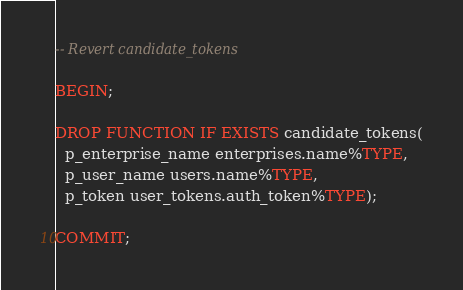Convert code to text. <code><loc_0><loc_0><loc_500><loc_500><_SQL_>-- Revert candidate_tokens

BEGIN;

DROP FUNCTION IF EXISTS candidate_tokens(
  p_enterprise_name enterprises.name%TYPE,
  p_user_name users.name%TYPE,
  p_token user_tokens.auth_token%TYPE);

COMMIT;
</code> 